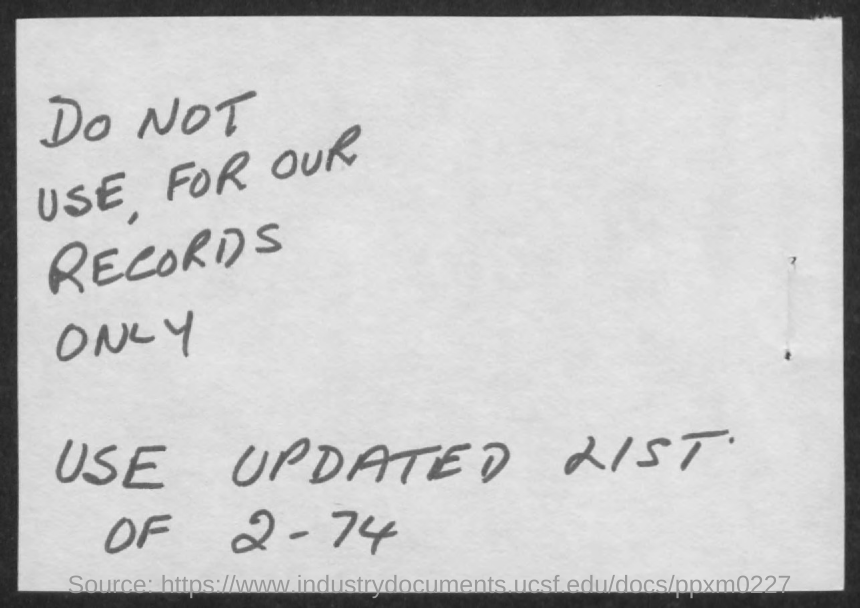What is the number mentioned in the document?
Ensure brevity in your answer.  2 - 74. 